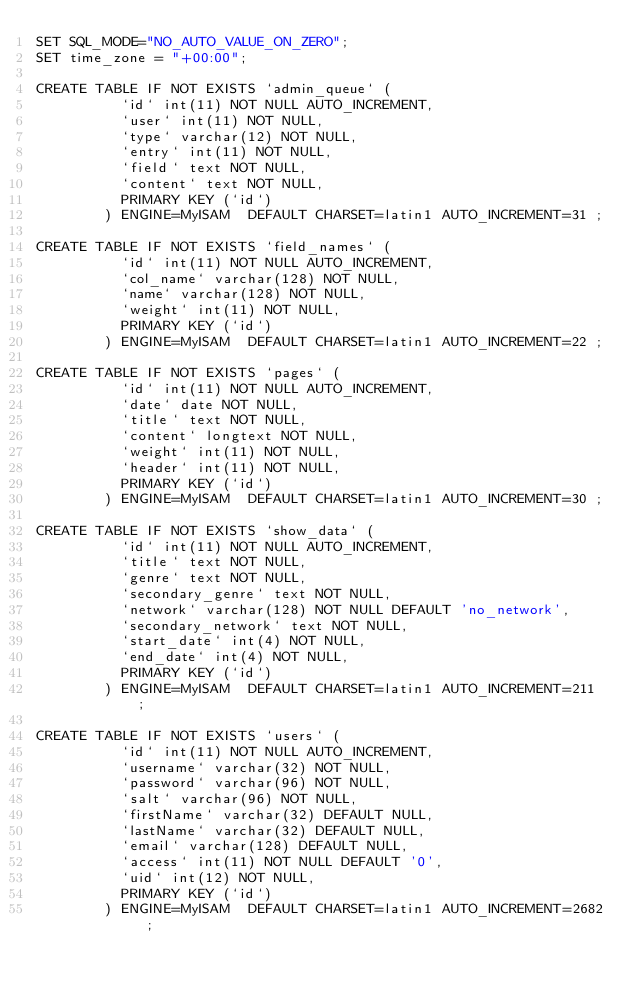<code> <loc_0><loc_0><loc_500><loc_500><_SQL_>SET SQL_MODE="NO_AUTO_VALUE_ON_ZERO";
SET time_zone = "+00:00";

CREATE TABLE IF NOT EXISTS `admin_queue` (
		  `id` int(11) NOT NULL AUTO_INCREMENT,
		  `user` int(11) NOT NULL,
		  `type` varchar(12) NOT NULL,
		  `entry` int(11) NOT NULL,
		  `field` text NOT NULL,
		  `content` text NOT NULL,
		  PRIMARY KEY (`id`)
		) ENGINE=MyISAM  DEFAULT CHARSET=latin1 AUTO_INCREMENT=31 ;

CREATE TABLE IF NOT EXISTS `field_names` (
		  `id` int(11) NOT NULL AUTO_INCREMENT,
		  `col_name` varchar(128) NOT NULL,
		  `name` varchar(128) NOT NULL,
		  `weight` int(11) NOT NULL,
		  PRIMARY KEY (`id`)
		) ENGINE=MyISAM  DEFAULT CHARSET=latin1 AUTO_INCREMENT=22 ;

CREATE TABLE IF NOT EXISTS `pages` (
		  `id` int(11) NOT NULL AUTO_INCREMENT,
		  `date` date NOT NULL,
		  `title` text NOT NULL,
		  `content` longtext NOT NULL,
		  `weight` int(11) NOT NULL,
		  `header` int(11) NOT NULL,
		  PRIMARY KEY (`id`)
		) ENGINE=MyISAM  DEFAULT CHARSET=latin1 AUTO_INCREMENT=30 ;

CREATE TABLE IF NOT EXISTS `show_data` (
		  `id` int(11) NOT NULL AUTO_INCREMENT,
		  `title` text NOT NULL,
		  `genre` text NOT NULL,
		  `secondary_genre` text NOT NULL,
		  `network` varchar(128) NOT NULL DEFAULT 'no_network',
		  `secondary_network` text NOT NULL,
		  `start_date` int(4) NOT NULL,
		  `end_date` int(4) NOT NULL,
		  PRIMARY KEY (`id`)
		) ENGINE=MyISAM  DEFAULT CHARSET=latin1 AUTO_INCREMENT=211 ;

CREATE TABLE IF NOT EXISTS `users` (
		  `id` int(11) NOT NULL AUTO_INCREMENT,
		  `username` varchar(32) NOT NULL,
		  `password` varchar(96) NOT NULL,
		  `salt` varchar(96) NOT NULL,
		  `firstName` varchar(32) DEFAULT NULL,
		  `lastName` varchar(32) DEFAULT NULL,
		  `email` varchar(128) DEFAULT NULL,
		  `access` int(11) NOT NULL DEFAULT '0',
		  `uid` int(12) NOT NULL,
		  PRIMARY KEY (`id`)
		) ENGINE=MyISAM  DEFAULT CHARSET=latin1 AUTO_INCREMENT=2682 ;

</code> 